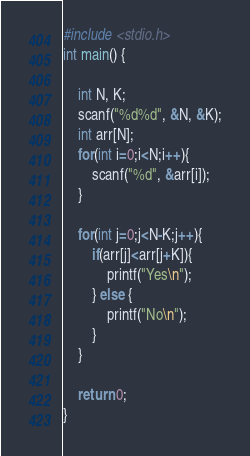Convert code to text. <code><loc_0><loc_0><loc_500><loc_500><_C_>#include <stdio.h>
int main() {
 
    int N, K;
    scanf("%d%d", &N, &K);
    int arr[N];
    for(int i=0;i<N;i++){
        scanf("%d", &arr[i]);
    }
 
    for(int j=0;j<N-K;j++){
        if(arr[j]<arr[j+K]){
            printf("Yes\n");
        } else {
            printf("No\n");
        }
    }
 
    return 0;
}</code> 